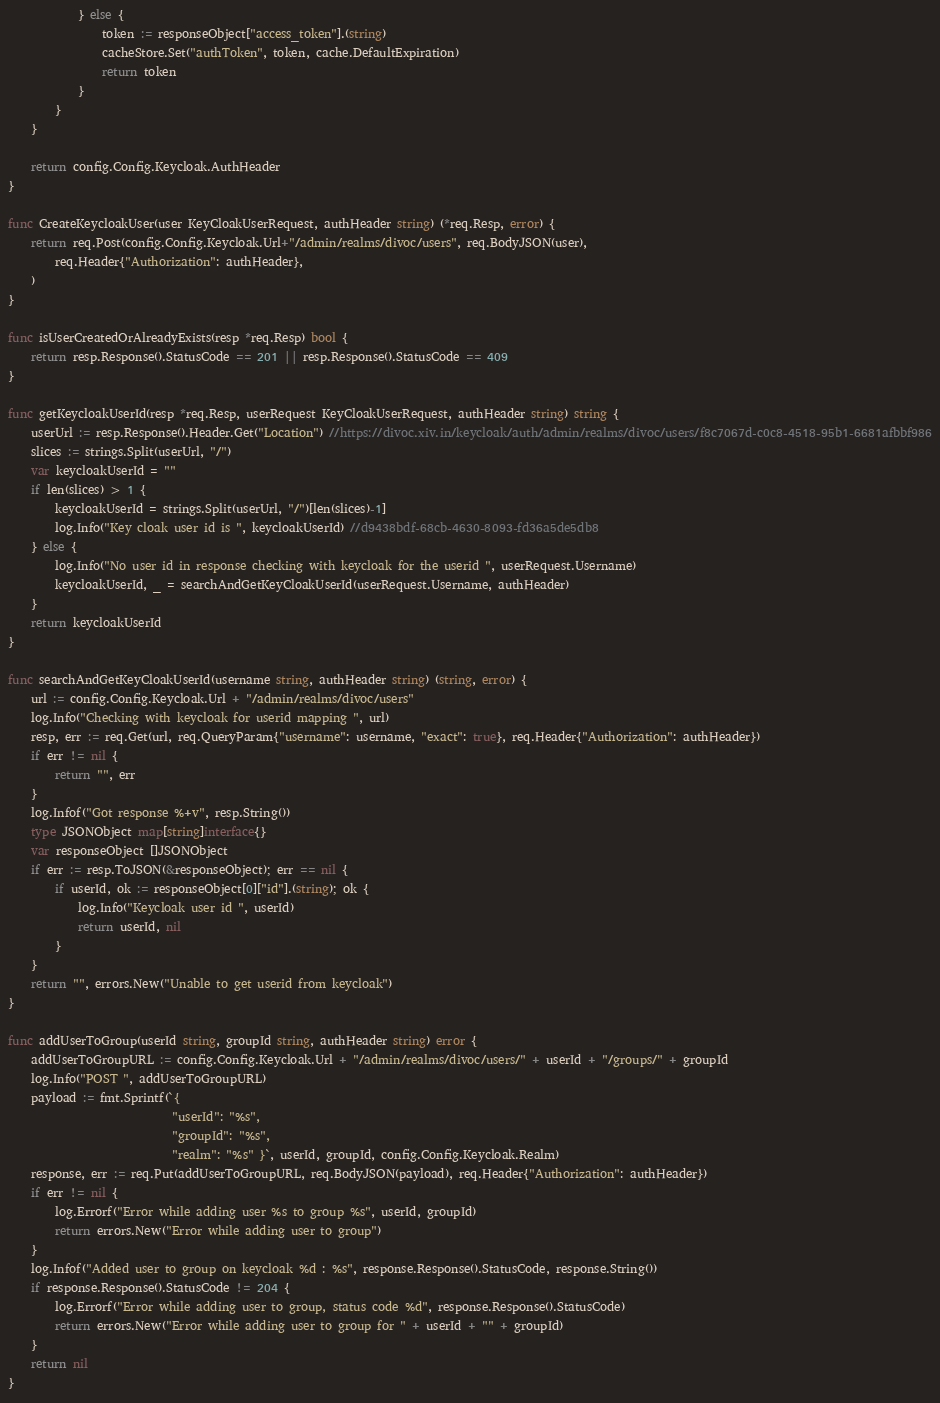<code> <loc_0><loc_0><loc_500><loc_500><_Go_>			} else {
				token := responseObject["access_token"].(string)
				cacheStore.Set("authToken", token, cache.DefaultExpiration)
				return token
			}
		}
	}

	return config.Config.Keycloak.AuthHeader
}

func CreateKeycloakUser(user KeyCloakUserRequest, authHeader string) (*req.Resp, error) {
	return req.Post(config.Config.Keycloak.Url+"/admin/realms/divoc/users", req.BodyJSON(user),
		req.Header{"Authorization": authHeader},
	)
}

func isUserCreatedOrAlreadyExists(resp *req.Resp) bool {
	return resp.Response().StatusCode == 201 || resp.Response().StatusCode == 409
}

func getKeycloakUserId(resp *req.Resp, userRequest KeyCloakUserRequest, authHeader string) string {
	userUrl := resp.Response().Header.Get("Location") //https://divoc.xiv.in/keycloak/auth/admin/realms/divoc/users/f8c7067d-c0c8-4518-95b1-6681afbbf986
	slices := strings.Split(userUrl, "/")
	var keycloakUserId = ""
	if len(slices) > 1 {
		keycloakUserId = strings.Split(userUrl, "/")[len(slices)-1]
		log.Info("Key cloak user id is ", keycloakUserId) //d9438bdf-68cb-4630-8093-fd36a5de5db8
	} else {
		log.Info("No user id in response checking with keycloak for the userid ", userRequest.Username)
		keycloakUserId, _ = searchAndGetKeyCloakUserId(userRequest.Username, authHeader)
	}
	return keycloakUserId
}

func searchAndGetKeyCloakUserId(username string, authHeader string) (string, error) {
	url := config.Config.Keycloak.Url + "/admin/realms/divoc/users"
	log.Info("Checking with keycloak for userid mapping ", url)
	resp, err := req.Get(url, req.QueryParam{"username": username, "exact": true}, req.Header{"Authorization": authHeader})
	if err != nil {
		return "", err
	}
	log.Infof("Got response %+v", resp.String())
	type JSONObject map[string]interface{}
	var responseObject []JSONObject
	if err := resp.ToJSON(&responseObject); err == nil {
		if userId, ok := responseObject[0]["id"].(string); ok {
			log.Info("Keycloak user id ", userId)
			return userId, nil
		}
	}
	return "", errors.New("Unable to get userid from keycloak")
}

func addUserToGroup(userId string, groupId string, authHeader string) error {
	addUserToGroupURL := config.Config.Keycloak.Url + "/admin/realms/divoc/users/" + userId + "/groups/" + groupId
	log.Info("POST ", addUserToGroupURL)
	payload := fmt.Sprintf(`{ 
							"userId": "%s",
							"groupId": "%s", 
							"realm": "%s" }`, userId, groupId, config.Config.Keycloak.Realm)
	response, err := req.Put(addUserToGroupURL, req.BodyJSON(payload), req.Header{"Authorization": authHeader})
	if err != nil {
		log.Errorf("Error while adding user %s to group %s", userId, groupId)
		return errors.New("Error while adding user to group")
	}
	log.Infof("Added user to group on keycloak %d : %s", response.Response().StatusCode, response.String())
	if response.Response().StatusCode != 204 {
		log.Errorf("Error while adding user to group, status code %d", response.Response().StatusCode)
		return errors.New("Error while adding user to group for " + userId + "" + groupId)
	}
	return nil
}


</code> 